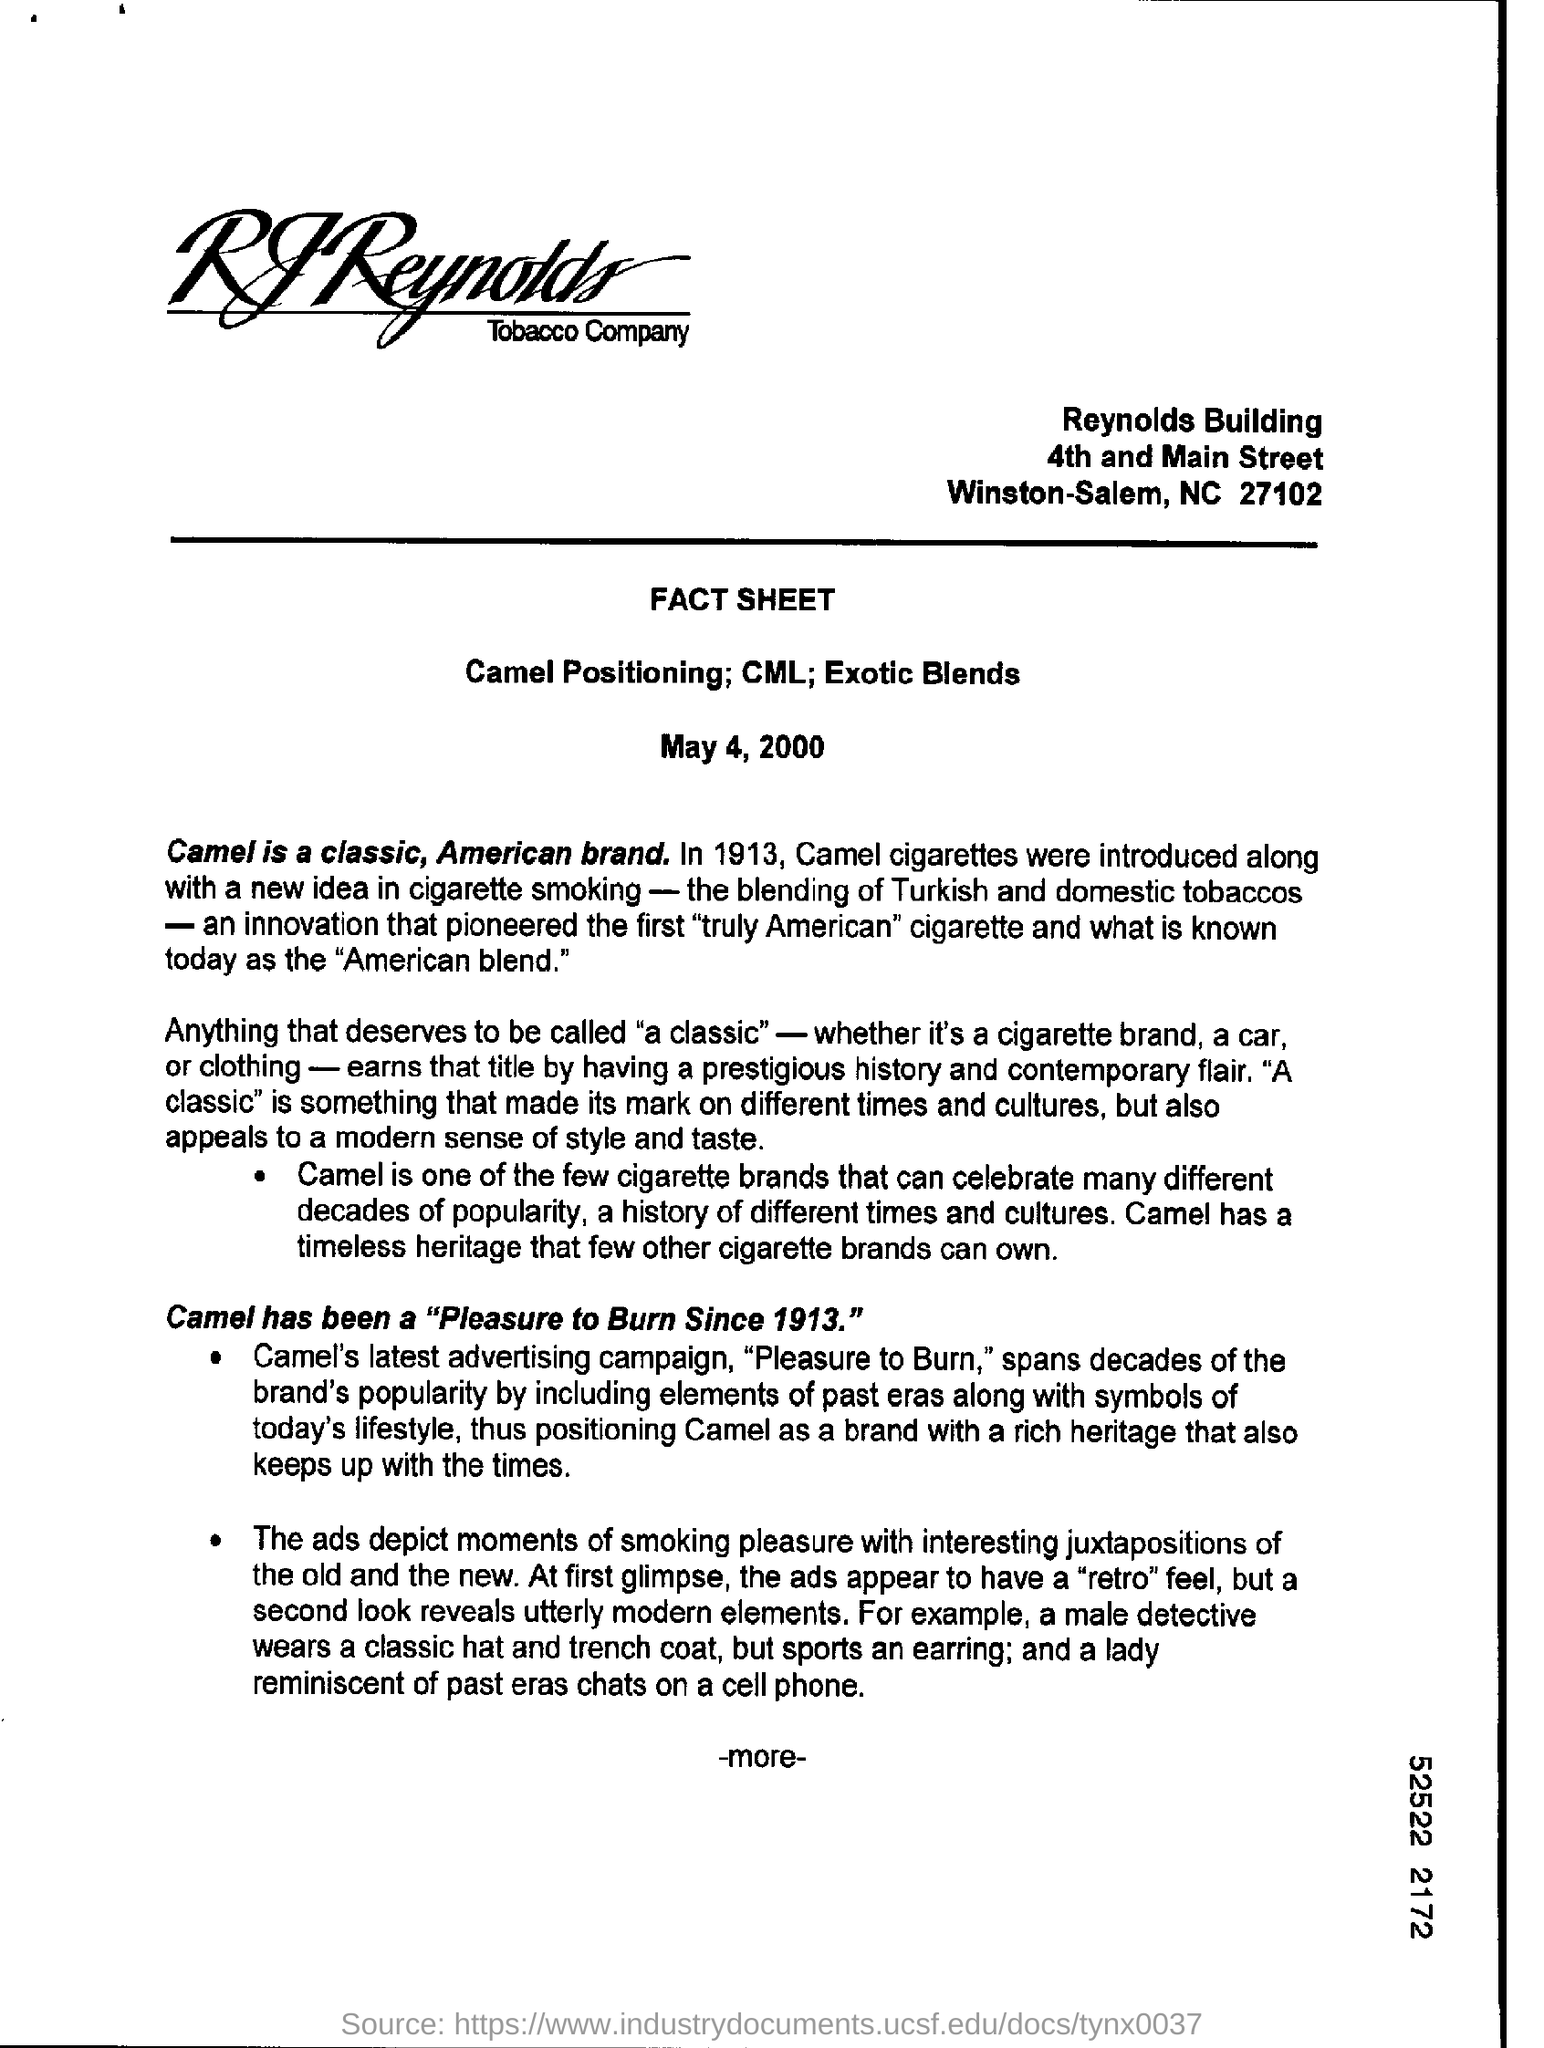What is the first line of the address mentioned at the top?
Make the answer very short. Reynolds Building. What is the date mentioned?
Provide a short and direct response. May 4, 2000. 